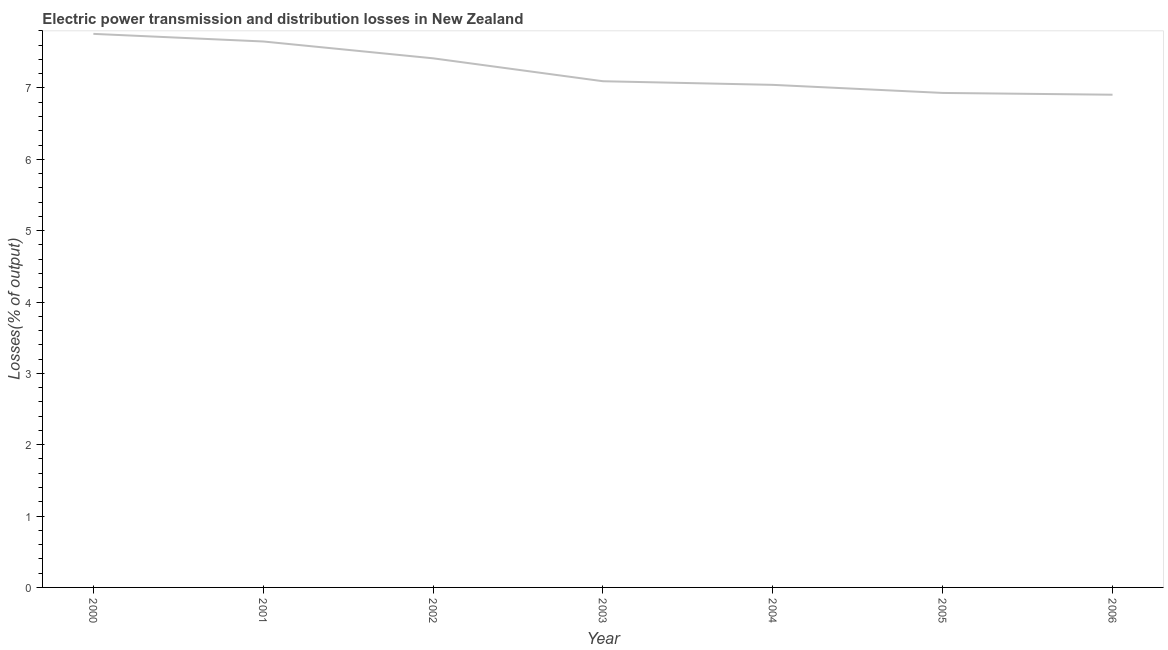What is the electric power transmission and distribution losses in 2001?
Offer a terse response. 7.65. Across all years, what is the maximum electric power transmission and distribution losses?
Ensure brevity in your answer.  7.76. Across all years, what is the minimum electric power transmission and distribution losses?
Your answer should be compact. 6.91. In which year was the electric power transmission and distribution losses maximum?
Give a very brief answer. 2000. What is the sum of the electric power transmission and distribution losses?
Keep it short and to the point. 50.8. What is the difference between the electric power transmission and distribution losses in 2001 and 2004?
Keep it short and to the point. 0.61. What is the average electric power transmission and distribution losses per year?
Give a very brief answer. 7.26. What is the median electric power transmission and distribution losses?
Your answer should be very brief. 7.09. Do a majority of the years between 2006 and 2005 (inclusive) have electric power transmission and distribution losses greater than 5.6 %?
Your answer should be very brief. No. What is the ratio of the electric power transmission and distribution losses in 2000 to that in 2006?
Your response must be concise. 1.12. Is the electric power transmission and distribution losses in 2002 less than that in 2006?
Provide a short and direct response. No. Is the difference between the electric power transmission and distribution losses in 2005 and 2006 greater than the difference between any two years?
Provide a succinct answer. No. What is the difference between the highest and the second highest electric power transmission and distribution losses?
Offer a terse response. 0.11. Is the sum of the electric power transmission and distribution losses in 2000 and 2006 greater than the maximum electric power transmission and distribution losses across all years?
Your answer should be compact. Yes. What is the difference between the highest and the lowest electric power transmission and distribution losses?
Your answer should be very brief. 0.85. In how many years, is the electric power transmission and distribution losses greater than the average electric power transmission and distribution losses taken over all years?
Give a very brief answer. 3. What is the title of the graph?
Provide a succinct answer. Electric power transmission and distribution losses in New Zealand. What is the label or title of the Y-axis?
Your answer should be very brief. Losses(% of output). What is the Losses(% of output) in 2000?
Provide a succinct answer. 7.76. What is the Losses(% of output) of 2001?
Keep it short and to the point. 7.65. What is the Losses(% of output) of 2002?
Provide a succinct answer. 7.42. What is the Losses(% of output) in 2003?
Offer a terse response. 7.09. What is the Losses(% of output) in 2004?
Your answer should be very brief. 7.04. What is the Losses(% of output) in 2005?
Your answer should be compact. 6.93. What is the Losses(% of output) of 2006?
Give a very brief answer. 6.91. What is the difference between the Losses(% of output) in 2000 and 2001?
Ensure brevity in your answer.  0.11. What is the difference between the Losses(% of output) in 2000 and 2002?
Your response must be concise. 0.34. What is the difference between the Losses(% of output) in 2000 and 2003?
Ensure brevity in your answer.  0.66. What is the difference between the Losses(% of output) in 2000 and 2004?
Provide a short and direct response. 0.71. What is the difference between the Losses(% of output) in 2000 and 2005?
Provide a short and direct response. 0.83. What is the difference between the Losses(% of output) in 2000 and 2006?
Keep it short and to the point. 0.85. What is the difference between the Losses(% of output) in 2001 and 2002?
Offer a very short reply. 0.24. What is the difference between the Losses(% of output) in 2001 and 2003?
Your answer should be very brief. 0.56. What is the difference between the Losses(% of output) in 2001 and 2004?
Offer a very short reply. 0.61. What is the difference between the Losses(% of output) in 2001 and 2005?
Your answer should be compact. 0.72. What is the difference between the Losses(% of output) in 2001 and 2006?
Your answer should be compact. 0.75. What is the difference between the Losses(% of output) in 2002 and 2003?
Your answer should be very brief. 0.32. What is the difference between the Losses(% of output) in 2002 and 2004?
Your response must be concise. 0.37. What is the difference between the Losses(% of output) in 2002 and 2005?
Provide a succinct answer. 0.49. What is the difference between the Losses(% of output) in 2002 and 2006?
Your answer should be compact. 0.51. What is the difference between the Losses(% of output) in 2003 and 2004?
Your response must be concise. 0.05. What is the difference between the Losses(% of output) in 2003 and 2005?
Give a very brief answer. 0.16. What is the difference between the Losses(% of output) in 2003 and 2006?
Provide a short and direct response. 0.19. What is the difference between the Losses(% of output) in 2004 and 2005?
Your answer should be compact. 0.11. What is the difference between the Losses(% of output) in 2004 and 2006?
Give a very brief answer. 0.14. What is the difference between the Losses(% of output) in 2005 and 2006?
Provide a short and direct response. 0.03. What is the ratio of the Losses(% of output) in 2000 to that in 2001?
Offer a terse response. 1.01. What is the ratio of the Losses(% of output) in 2000 to that in 2002?
Your answer should be very brief. 1.05. What is the ratio of the Losses(% of output) in 2000 to that in 2003?
Your response must be concise. 1.09. What is the ratio of the Losses(% of output) in 2000 to that in 2004?
Your answer should be very brief. 1.1. What is the ratio of the Losses(% of output) in 2000 to that in 2005?
Make the answer very short. 1.12. What is the ratio of the Losses(% of output) in 2000 to that in 2006?
Your answer should be very brief. 1.12. What is the ratio of the Losses(% of output) in 2001 to that in 2002?
Your answer should be very brief. 1.03. What is the ratio of the Losses(% of output) in 2001 to that in 2003?
Keep it short and to the point. 1.08. What is the ratio of the Losses(% of output) in 2001 to that in 2004?
Offer a terse response. 1.09. What is the ratio of the Losses(% of output) in 2001 to that in 2005?
Make the answer very short. 1.1. What is the ratio of the Losses(% of output) in 2001 to that in 2006?
Provide a succinct answer. 1.11. What is the ratio of the Losses(% of output) in 2002 to that in 2003?
Offer a terse response. 1.04. What is the ratio of the Losses(% of output) in 2002 to that in 2004?
Your answer should be very brief. 1.05. What is the ratio of the Losses(% of output) in 2002 to that in 2005?
Provide a succinct answer. 1.07. What is the ratio of the Losses(% of output) in 2002 to that in 2006?
Your answer should be compact. 1.07. What is the ratio of the Losses(% of output) in 2003 to that in 2004?
Ensure brevity in your answer.  1.01. What is the ratio of the Losses(% of output) in 2003 to that in 2005?
Give a very brief answer. 1.02. What is the ratio of the Losses(% of output) in 2004 to that in 2006?
Your answer should be very brief. 1.02. What is the ratio of the Losses(% of output) in 2005 to that in 2006?
Provide a short and direct response. 1. 